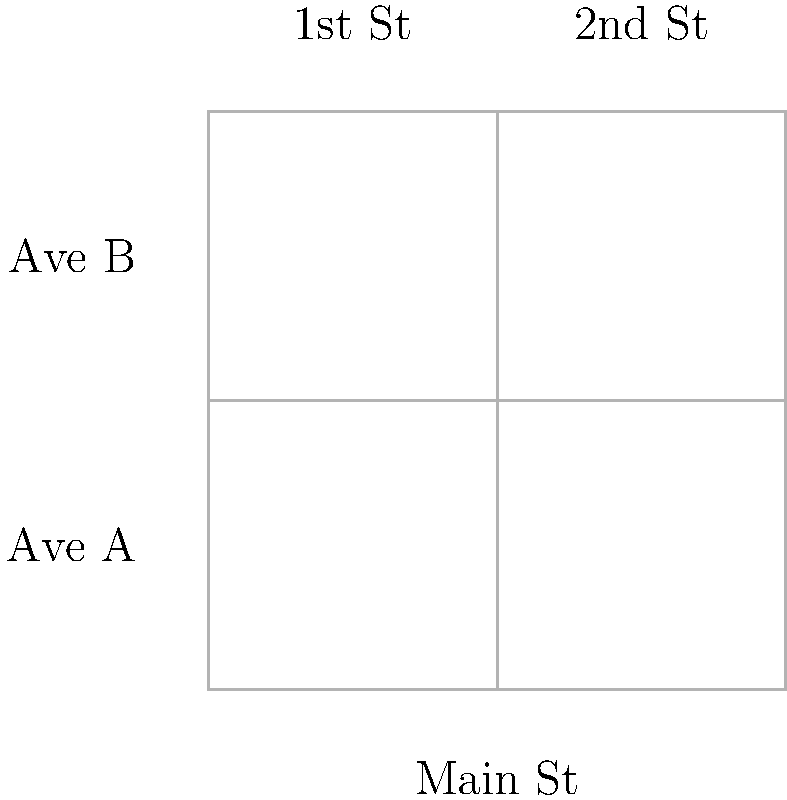Based on the street diagram of downtown Lovington, which intersection experiences the highest total traffic flow, and what is the combined number of vehicles passing through it per hour? To determine the intersection with the highest total traffic flow, we need to follow these steps:

1. Identify the intersections:
   - Main St & Ave A
   - Main St & Ave B
   - 1st St & Ave A
   - 1st St & Ave B
   - 2nd St & Ave A
   - 2nd St & Ave B

2. Calculate the total traffic flow for each intersection:
   - Main St & Ave A: 400 + 300 = 700 vehicles/hour
   - Main St & Ave B: 400 + 250 = 650 vehicles/hour
   - 1st St & Ave A: 0 + 300 = 300 vehicles/hour
   - 1st St & Ave B: 0 + 250 = 250 vehicles/hour
   - 2nd St & Ave A: 350 + 300 = 650 vehicles/hour
   - 2nd St & Ave B: 350 + 250 = 600 vehicles/hour

3. Identify the intersection with the highest total traffic flow:
   Main St & Ave A has the highest total with 700 vehicles/hour.

Therefore, the intersection of Main St and Ave A experiences the highest total traffic flow with 700 vehicles passing through it per hour.
Answer: Main St & Ave A, 700 vehicles/hour 